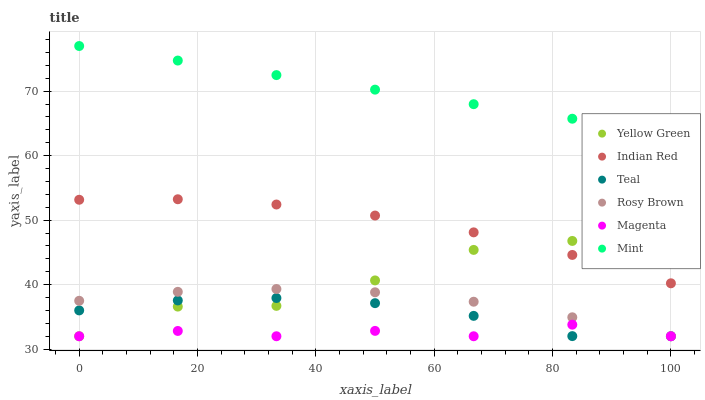Does Magenta have the minimum area under the curve?
Answer yes or no. Yes. Does Mint have the maximum area under the curve?
Answer yes or no. Yes. Does Rosy Brown have the minimum area under the curve?
Answer yes or no. No. Does Rosy Brown have the maximum area under the curve?
Answer yes or no. No. Is Mint the smoothest?
Answer yes or no. Yes. Is Yellow Green the roughest?
Answer yes or no. Yes. Is Rosy Brown the smoothest?
Answer yes or no. No. Is Rosy Brown the roughest?
Answer yes or no. No. Does Yellow Green have the lowest value?
Answer yes or no. Yes. Does Indian Red have the lowest value?
Answer yes or no. No. Does Mint have the highest value?
Answer yes or no. Yes. Does Rosy Brown have the highest value?
Answer yes or no. No. Is Magenta less than Indian Red?
Answer yes or no. Yes. Is Mint greater than Teal?
Answer yes or no. Yes. Does Magenta intersect Rosy Brown?
Answer yes or no. Yes. Is Magenta less than Rosy Brown?
Answer yes or no. No. Is Magenta greater than Rosy Brown?
Answer yes or no. No. Does Magenta intersect Indian Red?
Answer yes or no. No. 